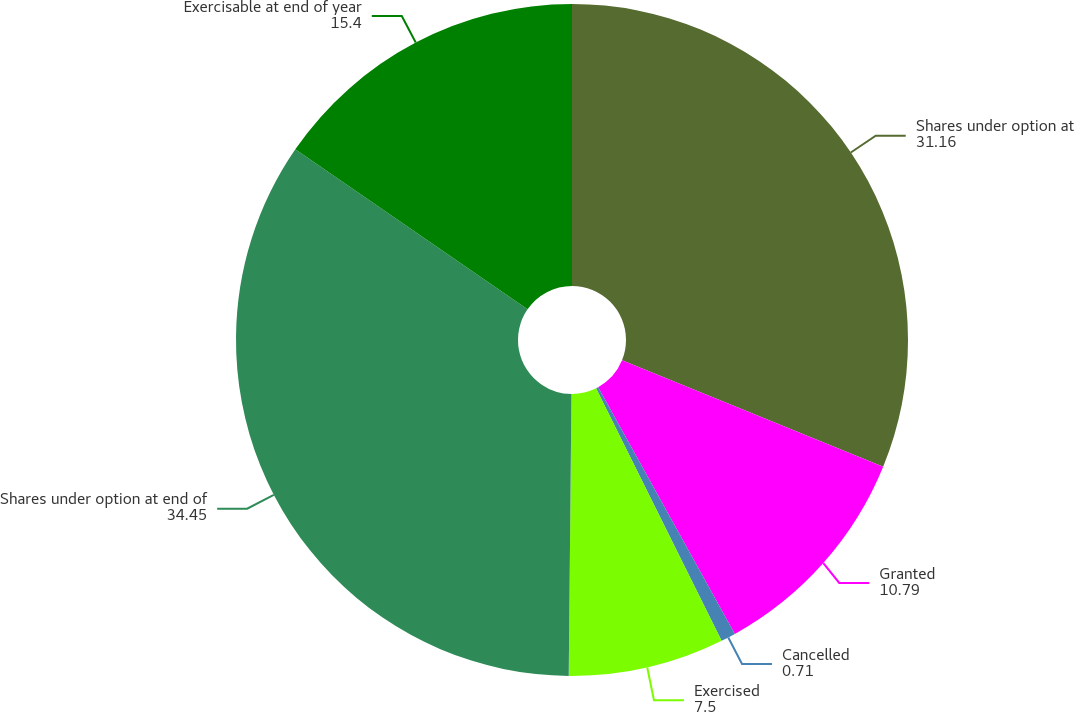<chart> <loc_0><loc_0><loc_500><loc_500><pie_chart><fcel>Shares under option at<fcel>Granted<fcel>Cancelled<fcel>Exercised<fcel>Shares under option at end of<fcel>Exercisable at end of year<nl><fcel>31.16%<fcel>10.79%<fcel>0.71%<fcel>7.5%<fcel>34.45%<fcel>15.4%<nl></chart> 